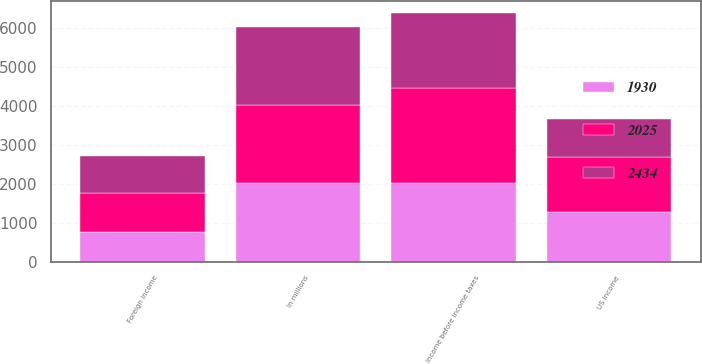Convert chart to OTSL. <chart><loc_0><loc_0><loc_500><loc_500><stacked_bar_chart><ecel><fcel>In millions<fcel>US income<fcel>Foreign income<fcel>Income before income taxes<nl><fcel>2434<fcel>2016<fcel>995<fcel>935<fcel>1930<nl><fcel>1930<fcel>2015<fcel>1275<fcel>750<fcel>2025<nl><fcel>2025<fcel>2014<fcel>1407<fcel>1027<fcel>2434<nl></chart> 